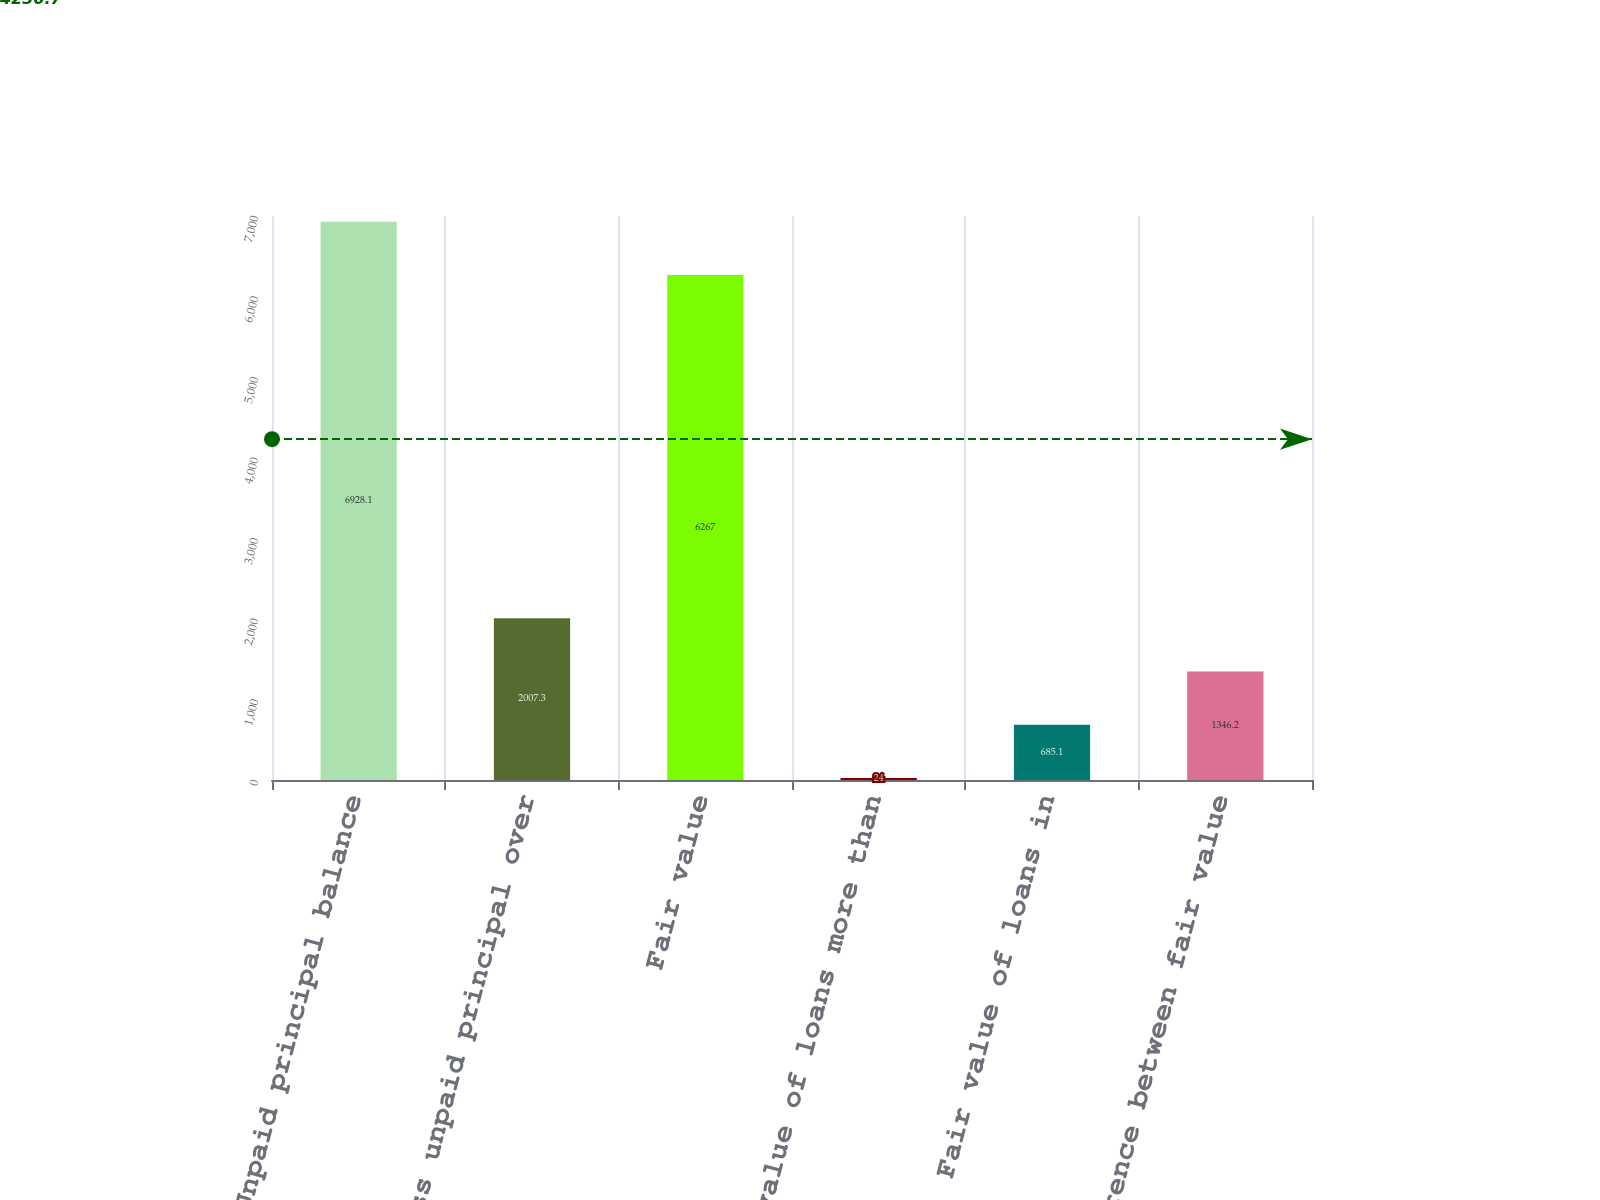<chart> <loc_0><loc_0><loc_500><loc_500><bar_chart><fcel>Unpaid principal balance<fcel>Excess unpaid principal over<fcel>Fair value<fcel>Fair value of loans more than<fcel>Fair value of loans in<fcel>Difference between fair value<nl><fcel>6928.1<fcel>2007.3<fcel>6267<fcel>24<fcel>685.1<fcel>1346.2<nl></chart> 